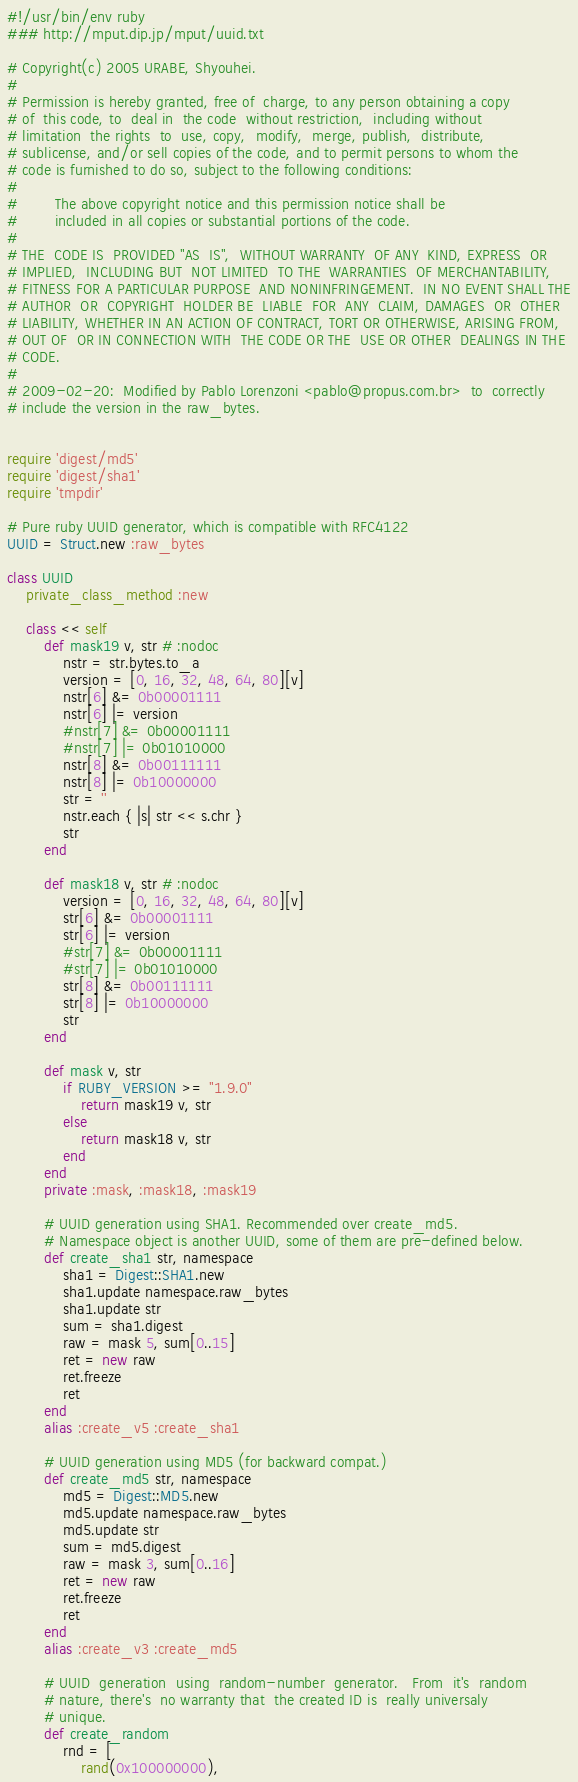Convert code to text. <code><loc_0><loc_0><loc_500><loc_500><_Ruby_>#!/usr/bin/env ruby
### http://mput.dip.jp/mput/uuid.txt

# Copyright(c) 2005 URABE, Shyouhei.
#
# Permission is hereby granted, free of  charge, to any person obtaining a copy
# of  this code, to  deal in  the code  without restriction,  including without
# limitation  the rights  to  use, copy,  modify,  merge, publish,  distribute,
# sublicense, and/or sell copies of the code, and to permit persons to whom the
# code is furnished to do so, subject to the following conditions:
#
#        The above copyright notice and this permission notice shall be
#        included in all copies or substantial portions of the code.
#
# THE  CODE IS  PROVIDED "AS  IS",  WITHOUT WARRANTY  OF ANY  KIND, EXPRESS  OR
# IMPLIED,  INCLUDING BUT  NOT LIMITED  TO THE  WARRANTIES  OF MERCHANTABILITY,
# FITNESS FOR A PARTICULAR PURPOSE  AND NONINFRINGEMENT.  IN NO EVENT SHALL THE
# AUTHOR  OR  COPYRIGHT  HOLDER BE  LIABLE  FOR  ANY  CLAIM, DAMAGES  OR  OTHER
# LIABILITY, WHETHER IN AN ACTION OF CONTRACT, TORT OR OTHERWISE, ARISING FROM,
# OUT OF  OR IN CONNECTION WITH  THE CODE OR THE  USE OR OTHER  DEALINGS IN THE
# CODE.
#
# 2009-02-20:  Modified by Pablo Lorenzoni <pablo@propus.com.br>  to  correctly
# include the version in the raw_bytes.


require 'digest/md5'
require 'digest/sha1'
require 'tmpdir'

# Pure ruby UUID generator, which is compatible with RFC4122
UUID = Struct.new :raw_bytes

class UUID
	private_class_method :new

	class << self
		def mask19 v, str # :nodoc
			nstr = str.bytes.to_a
			version = [0, 16, 32, 48, 64, 80][v]
			nstr[6] &= 0b00001111
			nstr[6] |= version
			#nstr[7] &= 0b00001111
			#nstr[7] |= 0b01010000
			nstr[8] &= 0b00111111
			nstr[8] |= 0b10000000
			str = ''
			nstr.each { |s| str << s.chr }
			str
		end

		def mask18 v, str # :nodoc
			version = [0, 16, 32, 48, 64, 80][v]
			str[6] &= 0b00001111
			str[6] |= version
			#str[7] &= 0b00001111
			#str[7] |= 0b01010000
			str[8] &= 0b00111111
			str[8] |= 0b10000000
			str
		end

		def mask v, str
			if RUBY_VERSION >= "1.9.0"
				return mask19 v, str
			else
				return mask18 v, str
			end
		end
		private :mask, :mask18, :mask19

		# UUID generation using SHA1. Recommended over create_md5.
		# Namespace object is another UUID, some of them are pre-defined below.
		def create_sha1 str, namespace
			sha1 = Digest::SHA1.new
			sha1.update namespace.raw_bytes
			sha1.update str
			sum = sha1.digest
			raw = mask 5, sum[0..15]
			ret = new raw
			ret.freeze
			ret
		end
		alias :create_v5 :create_sha1

		# UUID generation using MD5 (for backward compat.)
		def create_md5 str, namespace
			md5 = Digest::MD5.new
			md5.update namespace.raw_bytes
			md5.update str
			sum = md5.digest
			raw = mask 3, sum[0..16]
			ret = new raw
			ret.freeze
			ret
		end
		alias :create_v3 :create_md5

		# UUID  generation  using  random-number  generator.   From  it's  random
		# nature, there's  no warranty that  the created ID is  really universaly
		# unique.
		def create_random
			rnd = [
				rand(0x100000000),</code> 